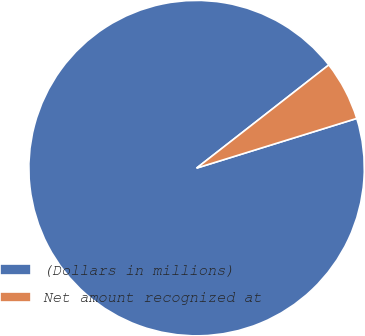Convert chart. <chart><loc_0><loc_0><loc_500><loc_500><pie_chart><fcel>(Dollars in millions)<fcel>Net amount recognized at<nl><fcel>94.24%<fcel>5.76%<nl></chart> 